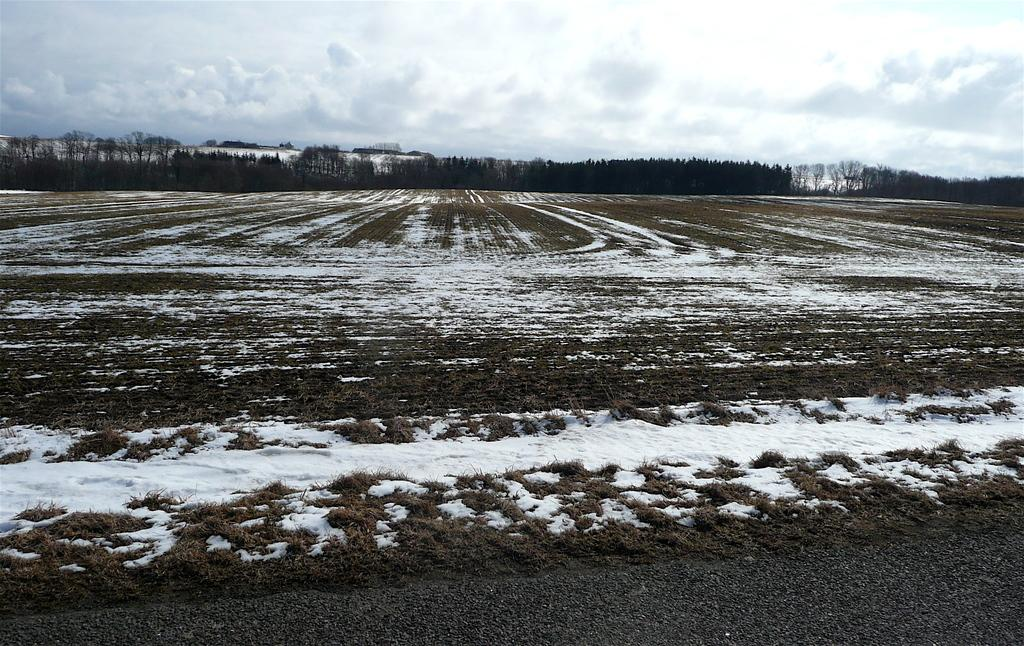What is the predominant weather condition in the image? There is snow in the image, indicating a cold and wintry condition. What type of vegetation can be seen in the image? There are trees and dried grass visible in the image. What is the appearance of the sky in the image? The sky is cloudy in the image. How many rabbits are hopping through the pickle in the image? There are no rabbits or pickles present in the image. What type of yarn is being used to create the snow in the image? The image does not depict any yarn being used to create the snow; it is a natural weather condition. 